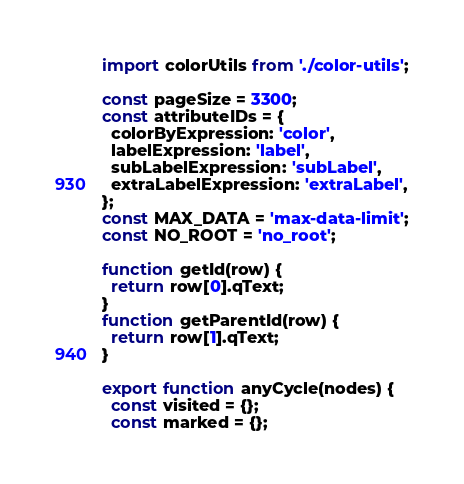<code> <loc_0><loc_0><loc_500><loc_500><_JavaScript_>import colorUtils from './color-utils';

const pageSize = 3300;
const attributeIDs = {
  colorByExpression: 'color',
  labelExpression: 'label',
  subLabelExpression: 'subLabel',
  extraLabelExpression: 'extraLabel',
};
const MAX_DATA = 'max-data-limit';
const NO_ROOT = 'no_root';

function getId(row) {
  return row[0].qText;
}
function getParentId(row) {
  return row[1].qText;
}

export function anyCycle(nodes) {
  const visited = {};
  const marked = {};</code> 